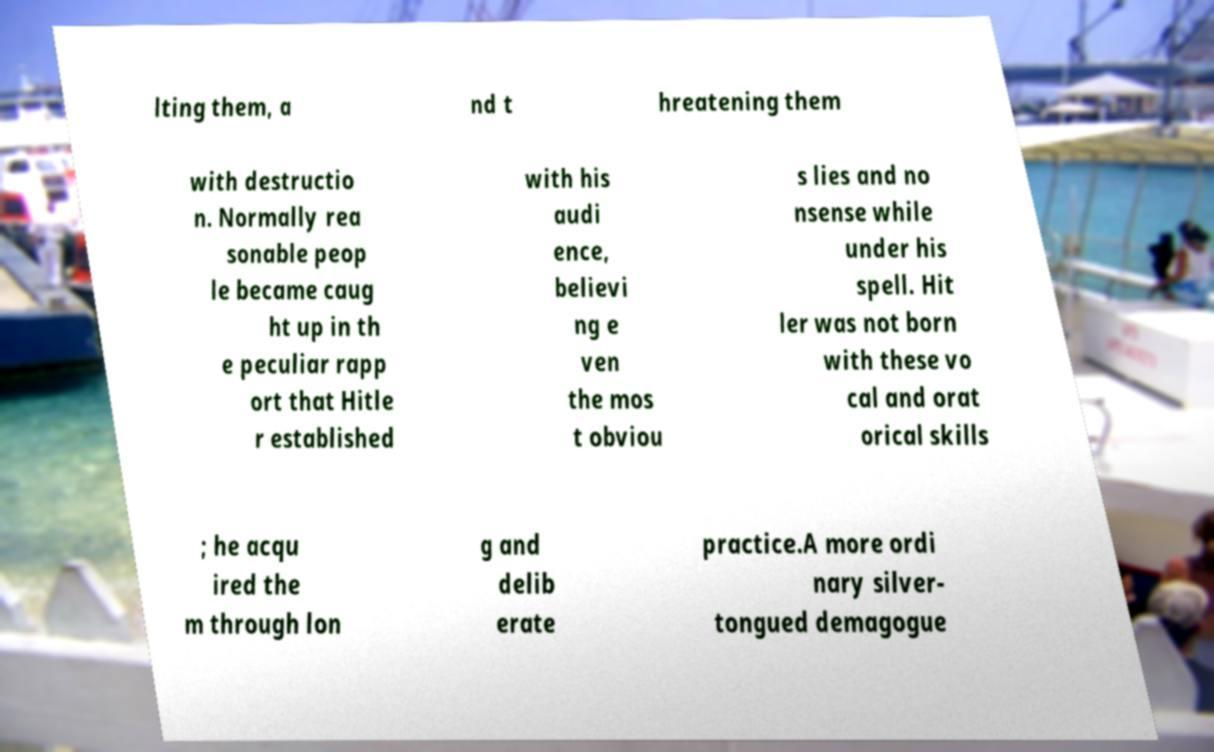There's text embedded in this image that I need extracted. Can you transcribe it verbatim? lting them, a nd t hreatening them with destructio n. Normally rea sonable peop le became caug ht up in th e peculiar rapp ort that Hitle r established with his audi ence, believi ng e ven the mos t obviou s lies and no nsense while under his spell. Hit ler was not born with these vo cal and orat orical skills ; he acqu ired the m through lon g and delib erate practice.A more ordi nary silver- tongued demagogue 